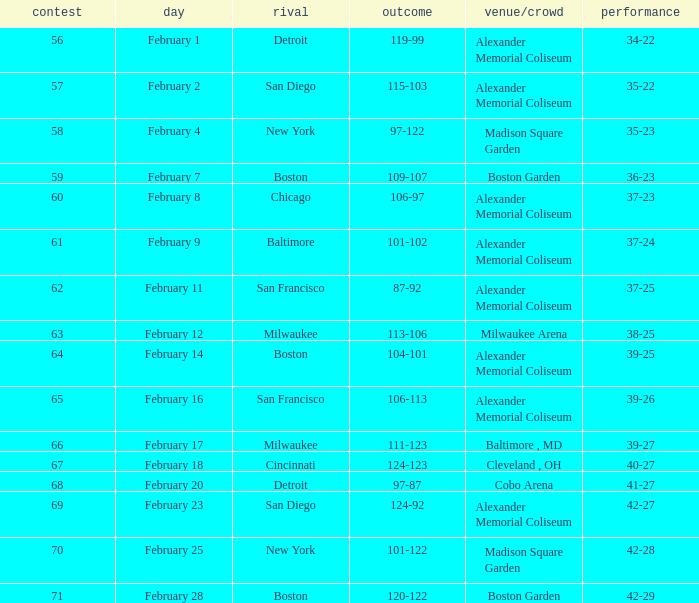What is the Game # that scored 87-92? 62.0. 